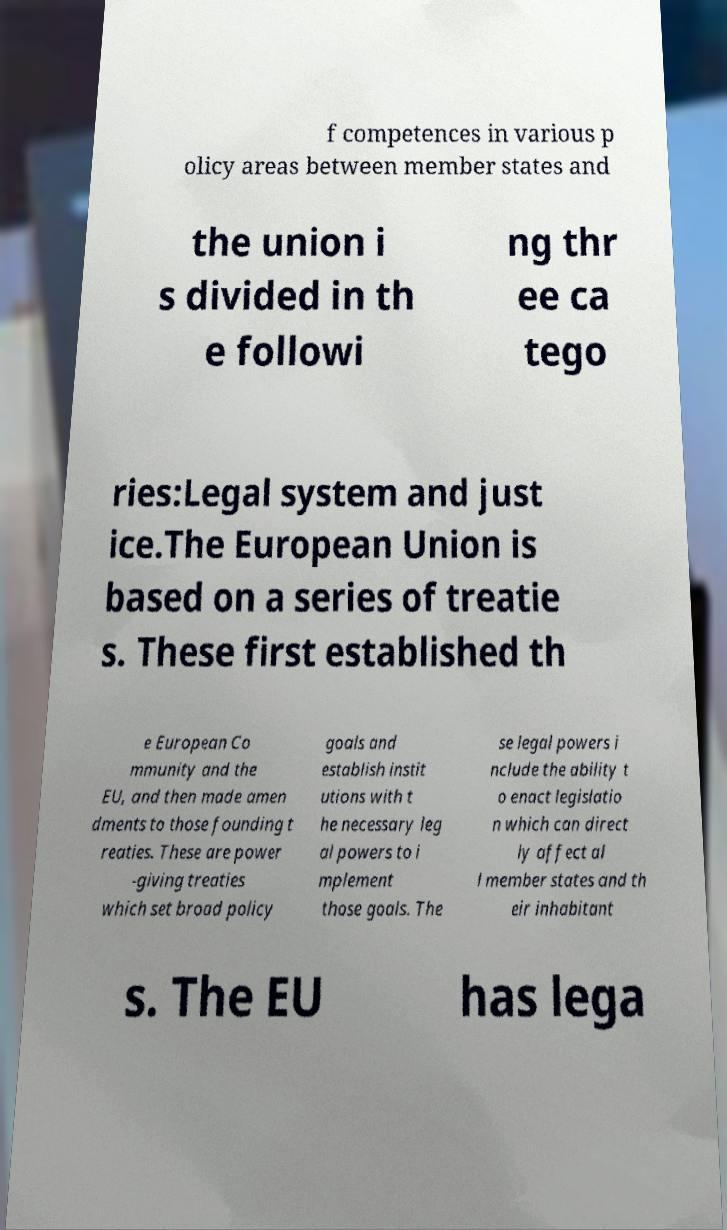For documentation purposes, I need the text within this image transcribed. Could you provide that? f competences in various p olicy areas between member states and the union i s divided in th e followi ng thr ee ca tego ries:Legal system and just ice.The European Union is based on a series of treatie s. These first established th e European Co mmunity and the EU, and then made amen dments to those founding t reaties. These are power -giving treaties which set broad policy goals and establish instit utions with t he necessary leg al powers to i mplement those goals. The se legal powers i nclude the ability t o enact legislatio n which can direct ly affect al l member states and th eir inhabitant s. The EU has lega 